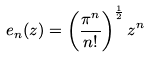Convert formula to latex. <formula><loc_0><loc_0><loc_500><loc_500>e _ { n } ( z ) = \left ( \frac { \pi ^ { n } } { n ! } \right ) ^ { \frac { 1 } { 2 } } z ^ { n }</formula> 